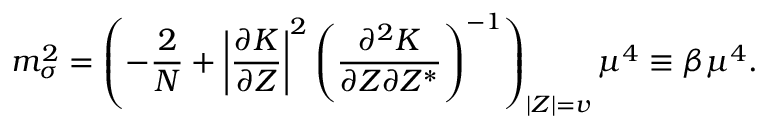Convert formula to latex. <formula><loc_0><loc_0><loc_500><loc_500>m _ { \sigma } ^ { 2 } = \left ( - \frac { 2 } { N } + \left | \frac { \partial K } { \partial Z } \right | ^ { 2 } \left ( \frac { \partial ^ { 2 } K } { \partial Z \partial Z ^ { * } } \right ) ^ { - 1 } \right ) _ { \left | Z \right | = v } \mu ^ { 4 } \equiv \beta \mu ^ { 4 } .</formula> 